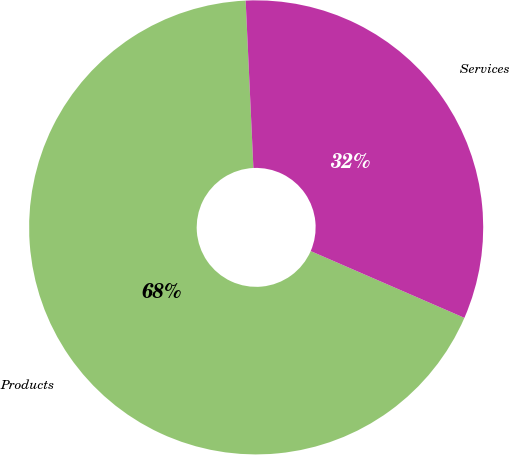<chart> <loc_0><loc_0><loc_500><loc_500><pie_chart><fcel>Products<fcel>Services<nl><fcel>67.74%<fcel>32.26%<nl></chart> 